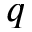<formula> <loc_0><loc_0><loc_500><loc_500>q</formula> 